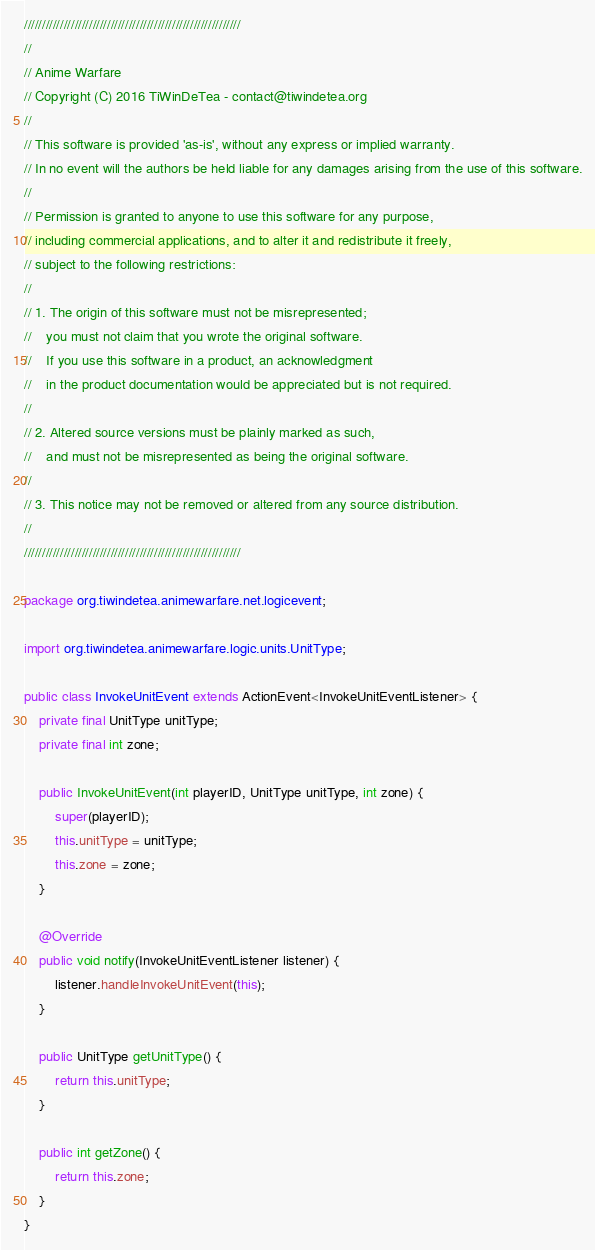<code> <loc_0><loc_0><loc_500><loc_500><_Java_>////////////////////////////////////////////////////////////
//
// Anime Warfare
// Copyright (C) 2016 TiWinDeTea - contact@tiwindetea.org
//
// This software is provided 'as-is', without any express or implied warranty.
// In no event will the authors be held liable for any damages arising from the use of this software.
//
// Permission is granted to anyone to use this software for any purpose,
// including commercial applications, and to alter it and redistribute it freely,
// subject to the following restrictions:
//
// 1. The origin of this software must not be misrepresented;
//    you must not claim that you wrote the original software.
//    If you use this software in a product, an acknowledgment
//    in the product documentation would be appreciated but is not required.
//
// 2. Altered source versions must be plainly marked as such,
//    and must not be misrepresented as being the original software.
//
// 3. This notice may not be removed or altered from any source distribution.
//
////////////////////////////////////////////////////////////

package org.tiwindetea.animewarfare.net.logicevent;

import org.tiwindetea.animewarfare.logic.units.UnitType;

public class InvokeUnitEvent extends ActionEvent<InvokeUnitEventListener> {
	private final UnitType unitType;
	private final int zone;

	public InvokeUnitEvent(int playerID, UnitType unitType, int zone) {
		super(playerID);
		this.unitType = unitType;
		this.zone = zone;
	}

	@Override
	public void notify(InvokeUnitEventListener listener) {
		listener.handleInvokeUnitEvent(this);
	}

	public UnitType getUnitType() {
		return this.unitType;
	}

	public int getZone() {
		return this.zone;
	}
}
</code> 